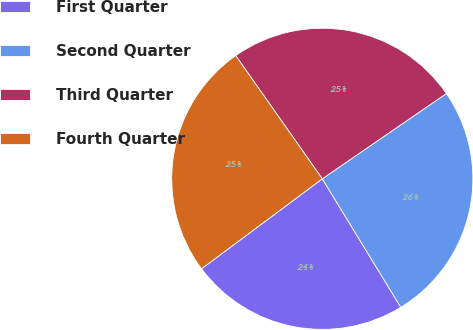Convert chart to OTSL. <chart><loc_0><loc_0><loc_500><loc_500><pie_chart><fcel>First Quarter<fcel>Second Quarter<fcel>Third Quarter<fcel>Fourth Quarter<nl><fcel>23.54%<fcel>25.85%<fcel>25.17%<fcel>25.44%<nl></chart> 